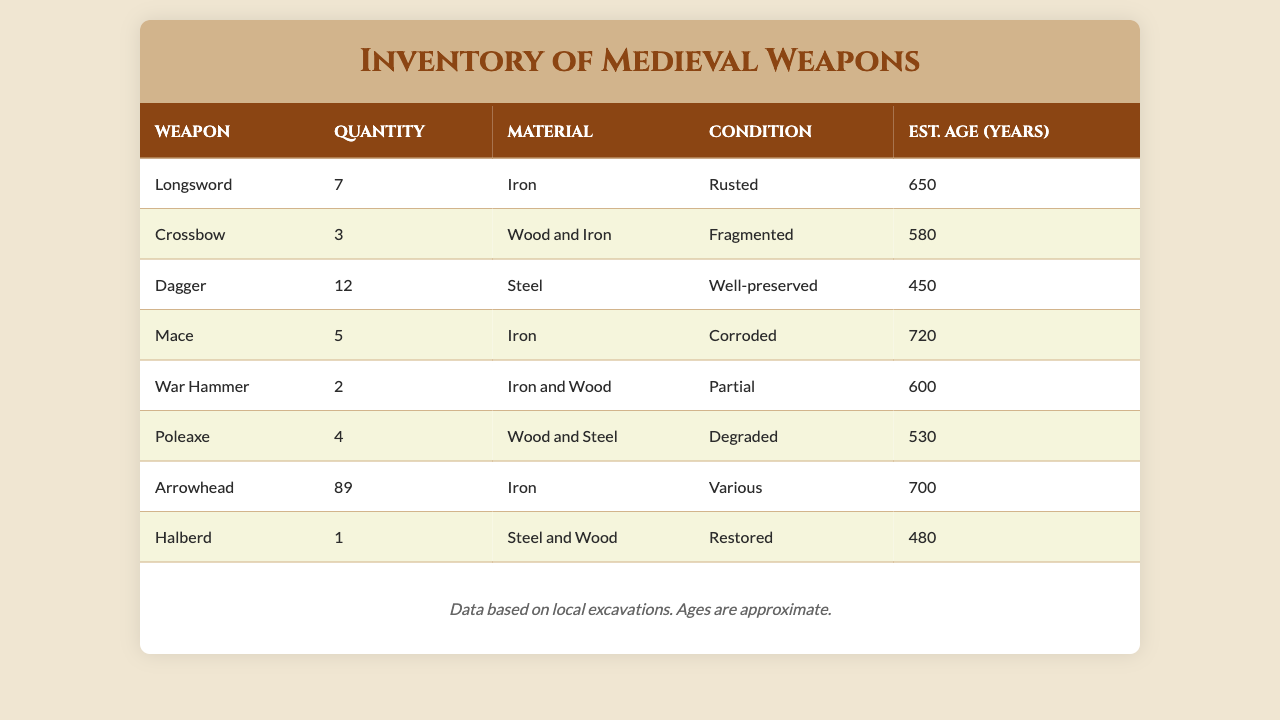What is the quantity of Dagger weapons found? The table shows that there are 12 Daggers listed under the quantity column.
Answer: 12 Which weapon has the highest estimated age? The weapon with the highest estimated age is the Mace, with an age of 720 years.
Answer: Mace What is the total quantity of Iron weapons listed? The Iron weapons listed are Longsword (7), Mace (5), War Hammer (2), and Arrowhead (89). Adding these gives 7 + 5 + 2 + 89 = 103.
Answer: 103 Is there any weapon listed as "Well-preserved"? Yes, the Dagger is the only weapon listed as "Well-preserved" in the condition column.
Answer: Yes How many weapons are in "Corroded" condition? The table has only one weapon listed as "Corroded," which is the Mace.
Answer: 1 What is the estimated average age of all weapons in the inventory? To find the average age, sum the ages: 650 + 580 + 450 + 720 + 600 + 530 + 700 + 480 = 4310. There are 8 weapons, so divide 4310 by 8, which equals 538.75.
Answer: 538.75 Are there more Crossbows or War Hammers? Crossbows have a quantity of 3 and War Hammers have a quantity of 2; therefore, there are more Crossbows.
Answer: Yes Which weapon has the least quantity? The weapon with the least quantity is the Halberd, with only 1 listed in the inventory.
Answer: Halberd How many weapons are made from both wood and iron? Only the Crossbow and the War Hammer are made from both wood and iron, which totals 2 weapons.
Answer: 2 If we combine the quantities of all weapons, what is the total? The total quantity is calculated by adding all quantities: 7 + 3 + 12 + 5 + 2 + 4 + 89 + 1 = 123.
Answer: 123 